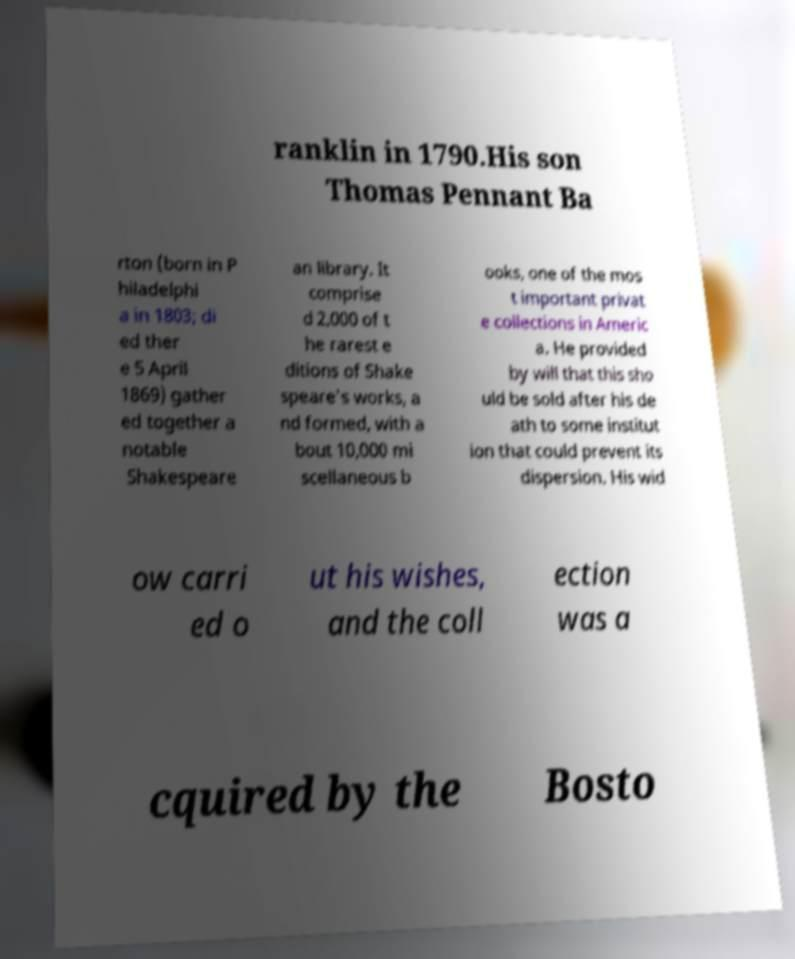Please read and relay the text visible in this image. What does it say? ranklin in 1790.His son Thomas Pennant Ba rton (born in P hiladelphi a in 1803; di ed ther e 5 April 1869) gather ed together a notable Shakespeare an library. It comprise d 2,000 of t he rarest e ditions of Shake speare's works, a nd formed, with a bout 10,000 mi scellaneous b ooks, one of the mos t important privat e collections in Americ a. He provided by will that this sho uld be sold after his de ath to some institut ion that could prevent its dispersion. His wid ow carri ed o ut his wishes, and the coll ection was a cquired by the Bosto 